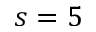Convert formula to latex. <formula><loc_0><loc_0><loc_500><loc_500>s = 5</formula> 